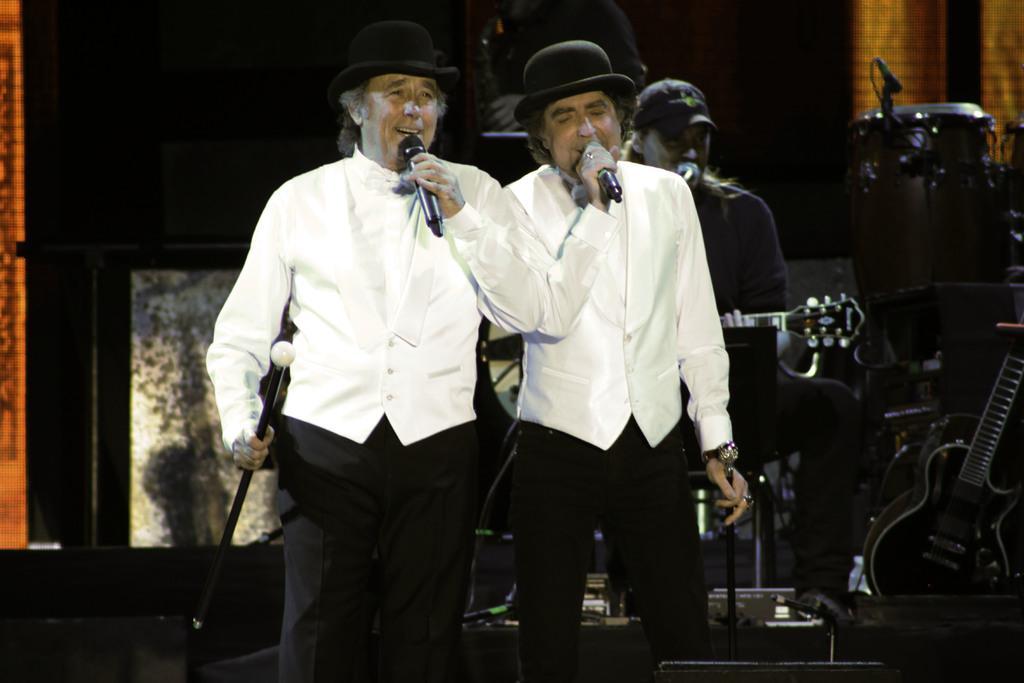Could you give a brief overview of what you see in this image? In the foreground of the image there are two people standing holding mic, wearing white color dress. In the background of the image there is a person playing guitar and there are musical instruments. 